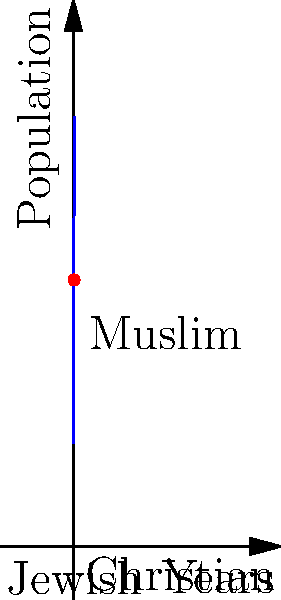As a city council member, you're analyzing population growth in three different neighborhoods: Muslim, Christian, and Jewish. The graph shows the combined population growth over 25 years, represented by the function $P(t) = 2000 + 500t - 10t^2$, where $t$ is time in years and $P(t)$ is the population. Calculate the total population increase across all three neighborhoods over the 25-year period. To find the total population increase, we need to calculate the area under the curve from $t=0$ to $t=25$. This can be done using definite integration:

1) The area under the curve is given by the definite integral:
   $$\int_0^{25} (2000 + 500t - 10t^2) dt$$

2) Integrate each term:
   $$\left[2000t + 250t^2 - \frac{10}{3}t^3\right]_0^{25}$$

3) Evaluate at the upper and lower bounds:
   $$(2000(25) + 250(25^2) - \frac{10}{3}(25^3)) - (2000(0) + 250(0^2) - \frac{10}{3}(0^3))$$

4) Simplify:
   $$(50000 + 156250 - 52083.33) - 0 = 154166.67$$

5) Round to the nearest whole number:
   154,167

This represents the total increase in population across all three neighborhoods over the 25-year period.
Answer: 154,167 people 